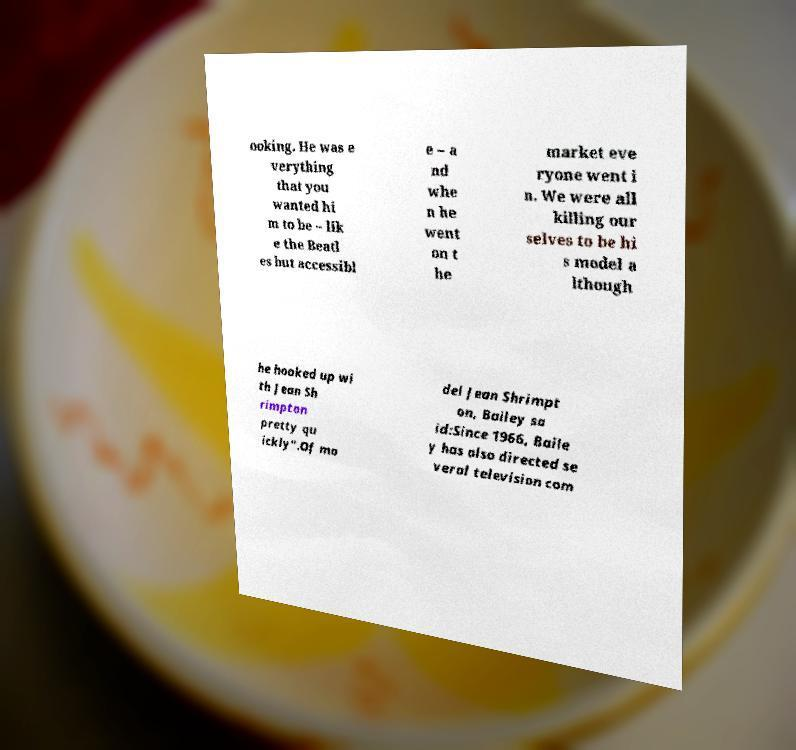What messages or text are displayed in this image? I need them in a readable, typed format. ooking. He was e verything that you wanted hi m to be – lik e the Beatl es but accessibl e – a nd whe n he went on t he market eve ryone went i n. We were all killing our selves to be hi s model a lthough he hooked up wi th Jean Sh rimpton pretty qu ickly".Of mo del Jean Shrimpt on, Bailey sa id:Since 1966, Baile y has also directed se veral television com 